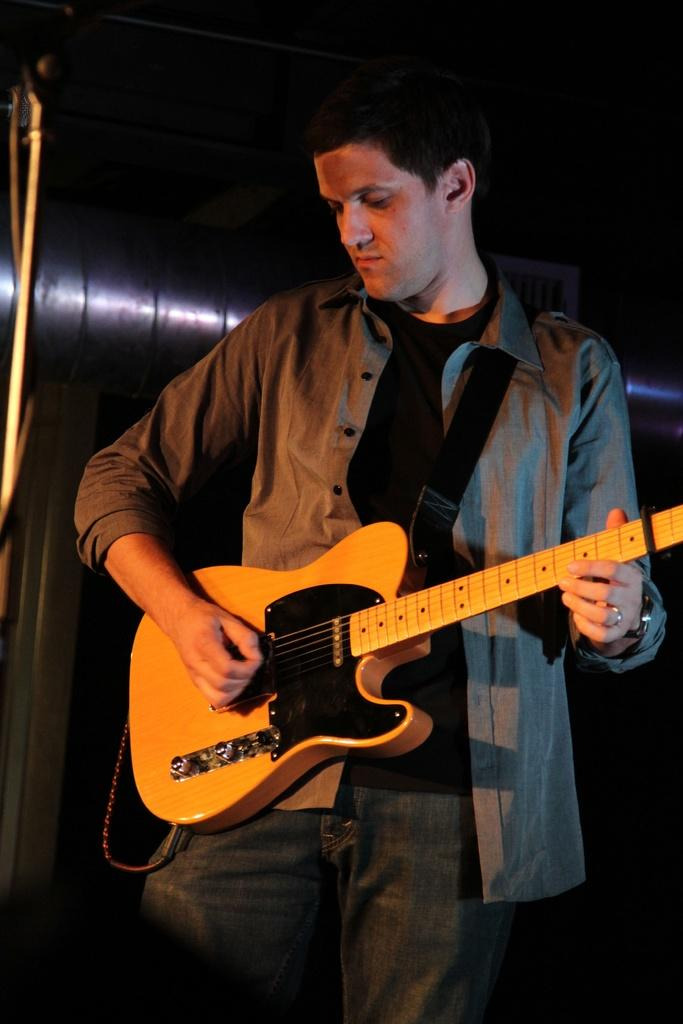What is the man in the image doing? The man is playing the guitar. What object is the man holding in the image? The man is holding a guitar. What can be seen in the background of the image? There is a pipe, a stand, and a blurred area in the background of the image. What type of wax is being used to create the guitar in the image? There is no wax being used to create the guitar in the image; it is a real guitar being played by the man. 